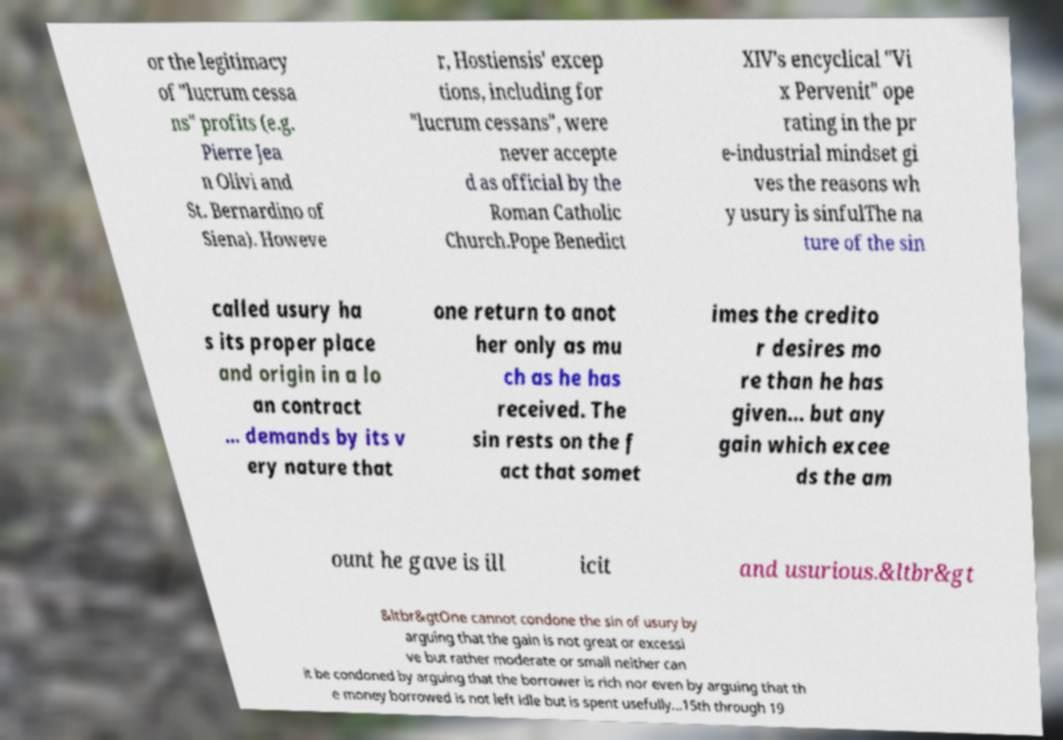There's text embedded in this image that I need extracted. Can you transcribe it verbatim? or the legitimacy of "lucrum cessa ns" profits (e.g. Pierre Jea n Olivi and St. Bernardino of Siena). Howeve r, Hostiensis' excep tions, including for "lucrum cessans", were never accepte d as official by the Roman Catholic Church.Pope Benedict XIV's encyclical "Vi x Pervenit" ope rating in the pr e-industrial mindset gi ves the reasons wh y usury is sinfulThe na ture of the sin called usury ha s its proper place and origin in a lo an contract … demands by its v ery nature that one return to anot her only as mu ch as he has received. The sin rests on the f act that somet imes the credito r desires mo re than he has given… but any gain which excee ds the am ount he gave is ill icit and usurious.&ltbr&gt &ltbr&gtOne cannot condone the sin of usury by arguing that the gain is not great or excessi ve but rather moderate or small neither can it be condoned by arguing that the borrower is rich nor even by arguing that th e money borrowed is not left idle but is spent usefully…15th through 19 